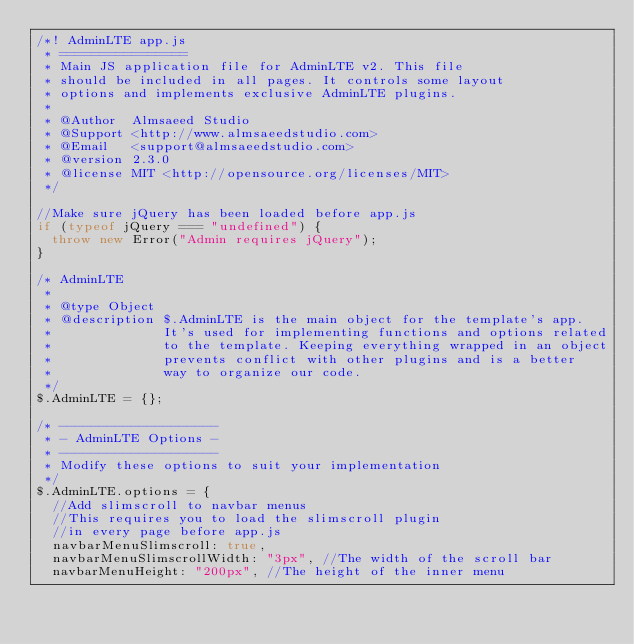Convert code to text. <code><loc_0><loc_0><loc_500><loc_500><_JavaScript_>/*! AdminLTE app.js
 * ================
 * Main JS application file for AdminLTE v2. This file
 * should be included in all pages. It controls some layout
 * options and implements exclusive AdminLTE plugins.
 *
 * @Author  Almsaeed Studio
 * @Support <http://www.almsaeedstudio.com>
 * @Email   <support@almsaeedstudio.com>
 * @version 2.3.0
 * @license MIT <http://opensource.org/licenses/MIT>
 */

//Make sure jQuery has been loaded before app.js
if (typeof jQuery === "undefined") {
  throw new Error("Admin requires jQuery");
}

/* AdminLTE
 *
 * @type Object
 * @description $.AdminLTE is the main object for the template's app.
 *              It's used for implementing functions and options related
 *              to the template. Keeping everything wrapped in an object
 *              prevents conflict with other plugins and is a better
 *              way to organize our code.
 */
$.AdminLTE = {};

/* --------------------
 * - AdminLTE Options -
 * --------------------
 * Modify these options to suit your implementation
 */
$.AdminLTE.options = {
  //Add slimscroll to navbar menus
  //This requires you to load the slimscroll plugin
  //in every page before app.js
  navbarMenuSlimscroll: true,
  navbarMenuSlimscrollWidth: "3px", //The width of the scroll bar
  navbarMenuHeight: "200px", //The height of the inner menu</code> 